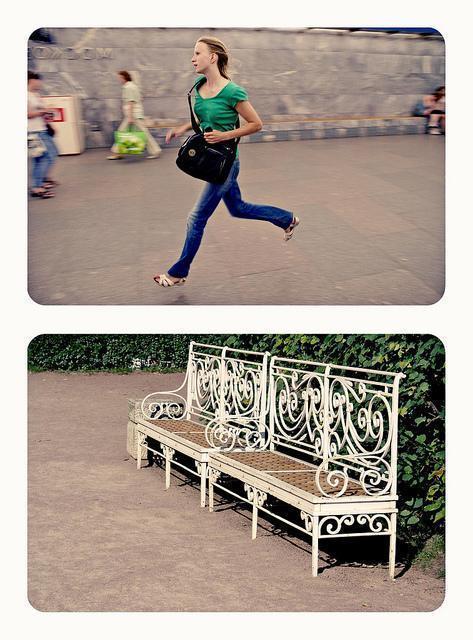Which country invented free public benches?
Make your selection from the four choices given to correctly answer the question.
Options: Belgium, france, america, italy. France. 